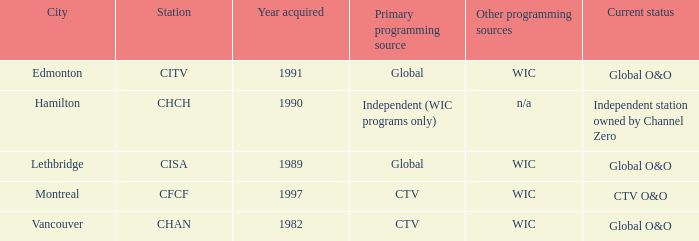Which station is located in edmonton CITV. 